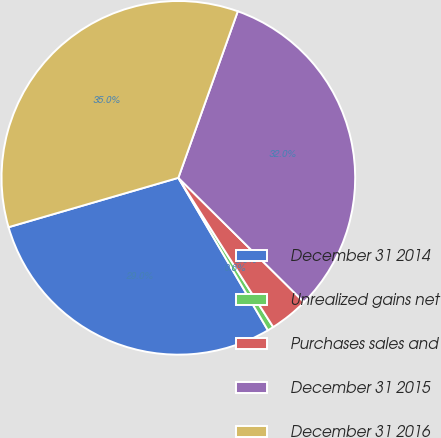<chart> <loc_0><loc_0><loc_500><loc_500><pie_chart><fcel>December 31 2014<fcel>Unrealized gains net<fcel>Purchases sales and<fcel>December 31 2015<fcel>December 31 2016<nl><fcel>28.95%<fcel>0.56%<fcel>3.57%<fcel>31.96%<fcel>34.96%<nl></chart> 